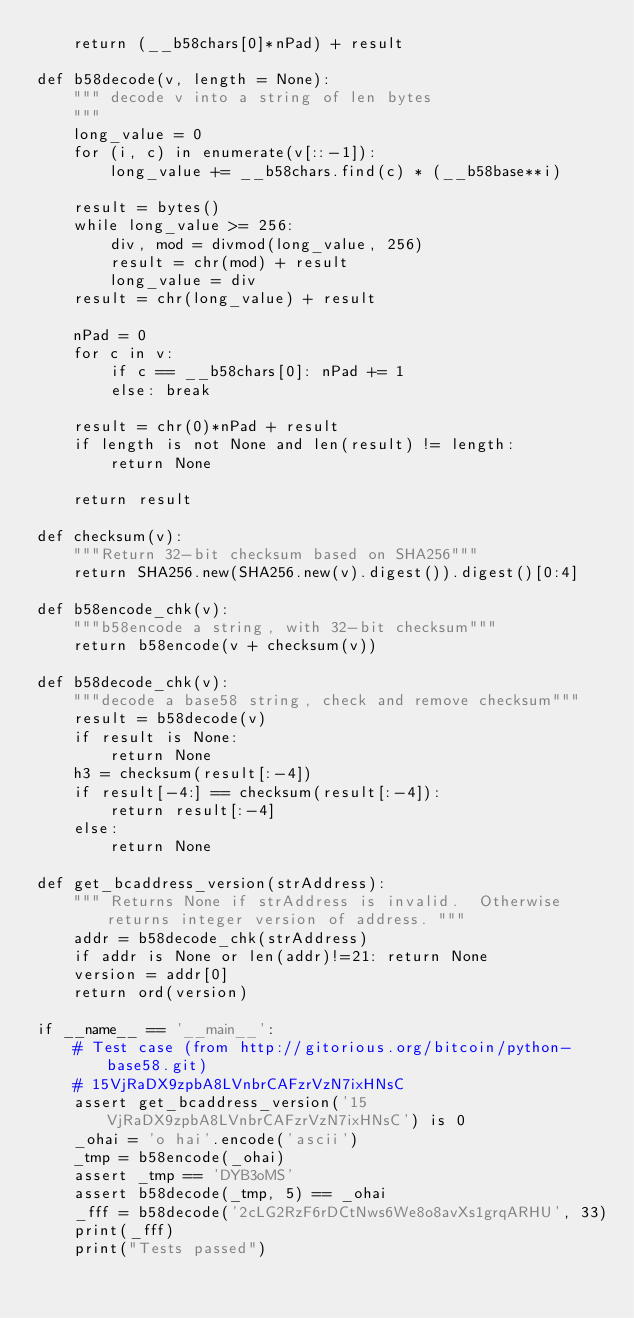<code> <loc_0><loc_0><loc_500><loc_500><_Python_>    return (__b58chars[0]*nPad) + result

def b58decode(v, length = None):
    """ decode v into a string of len bytes
    """
    long_value = 0
    for (i, c) in enumerate(v[::-1]):
        long_value += __b58chars.find(c) * (__b58base**i)

    result = bytes()
    while long_value >= 256:
        div, mod = divmod(long_value, 256)
        result = chr(mod) + result
        long_value = div
    result = chr(long_value) + result

    nPad = 0
    for c in v:
        if c == __b58chars[0]: nPad += 1
        else: break

    result = chr(0)*nPad + result
    if length is not None and len(result) != length:
        return None

    return result

def checksum(v):
    """Return 32-bit checksum based on SHA256"""
    return SHA256.new(SHA256.new(v).digest()).digest()[0:4]

def b58encode_chk(v):
    """b58encode a string, with 32-bit checksum"""
    return b58encode(v + checksum(v))

def b58decode_chk(v):
    """decode a base58 string, check and remove checksum"""
    result = b58decode(v)
    if result is None:
        return None
    h3 = checksum(result[:-4])
    if result[-4:] == checksum(result[:-4]):
        return result[:-4]
    else:
        return None

def get_bcaddress_version(strAddress):
    """ Returns None if strAddress is invalid.  Otherwise returns integer version of address. """
    addr = b58decode_chk(strAddress)
    if addr is None or len(addr)!=21: return None
    version = addr[0]
    return ord(version)

if __name__ == '__main__':
    # Test case (from http://gitorious.org/bitcoin/python-base58.git)
    # 15VjRaDX9zpbA8LVnbrCAFzrVzN7ixHNsC
    assert get_bcaddress_version('15VjRaDX9zpbA8LVnbrCAFzrVzN7ixHNsC') is 0
    _ohai = 'o hai'.encode('ascii')
    _tmp = b58encode(_ohai)
    assert _tmp == 'DYB3oMS'
    assert b58decode(_tmp, 5) == _ohai
    _fff = b58decode('2cLG2RzF6rDCtNws6We8o8avXs1grqARHU', 33)
    print(_fff)
    print("Tests passed")</code> 